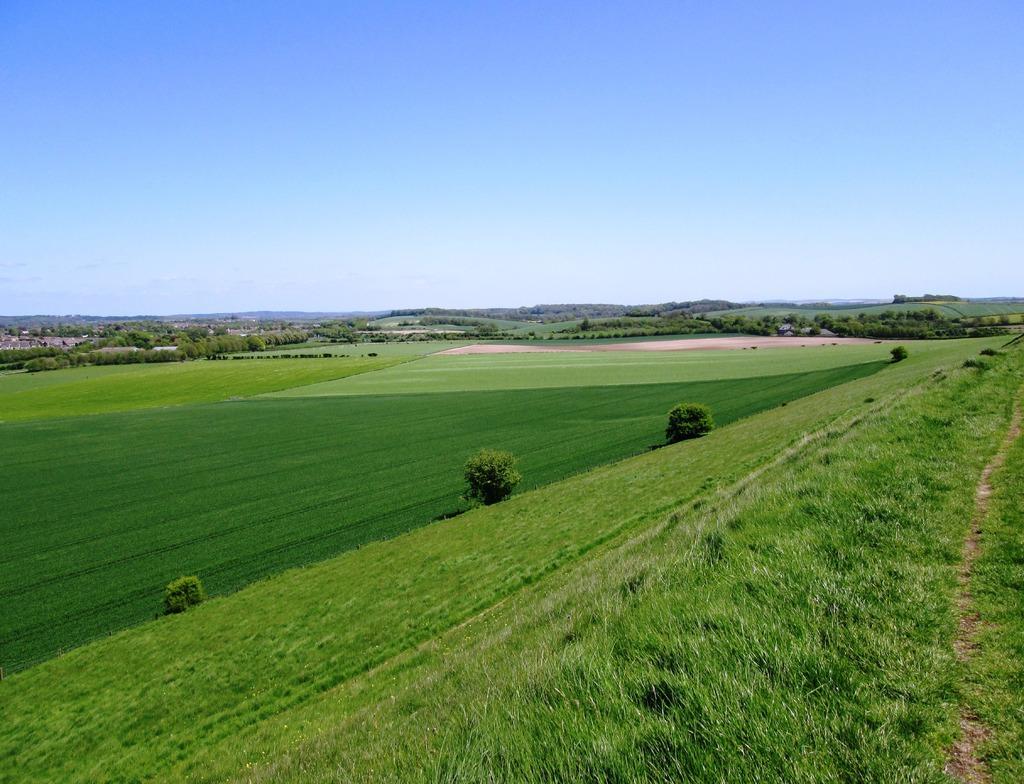Could you give a brief overview of what you see in this image? This image is taken outdoors. At the top of the image there is a sky. At the bottom of the image there is a ground with grass, a few plants and trees on it. 